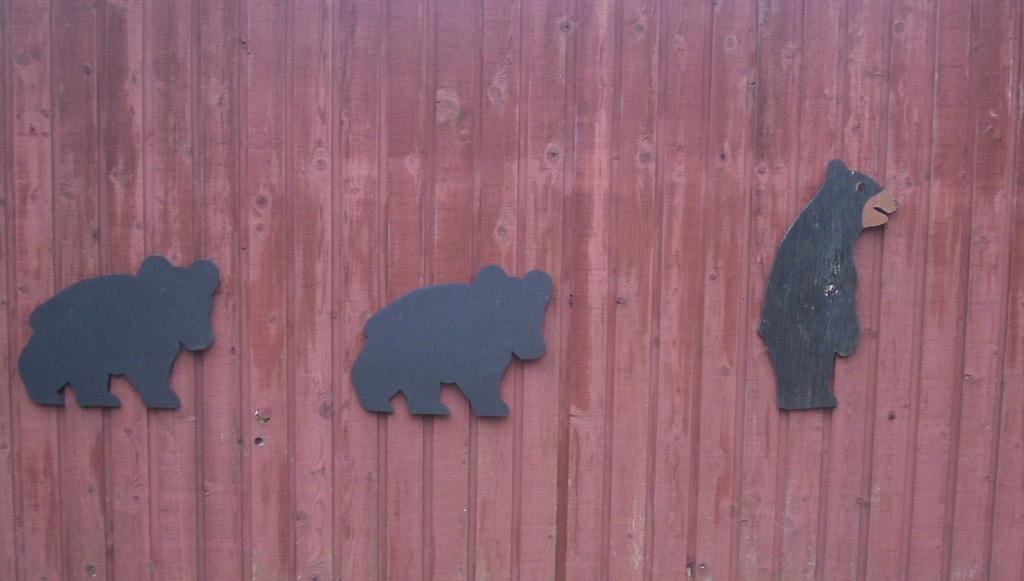What is the color of the surface in the image? The surface in the image is brown. What can be seen on the surface? There are two black objects on the surface. What is depicted in the image besides the black objects? There is a depiction of an animal in the image. How does the image contribute to the pollution in the area? The image itself does not contribute to pollution; it is a static representation. 